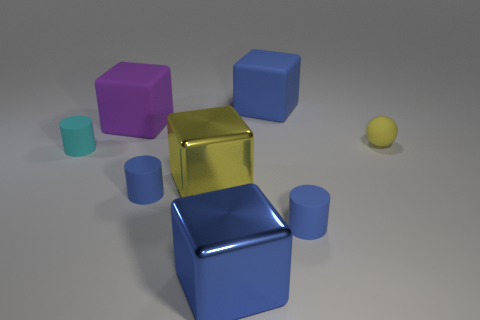Subtract 1 blocks. How many blocks are left? 3 Subtract all green spheres. Subtract all red cubes. How many spheres are left? 1 Add 1 purple things. How many objects exist? 9 Subtract all spheres. How many objects are left? 7 Add 2 tiny cyan rubber cylinders. How many tiny cyan rubber cylinders are left? 3 Add 7 large purple blocks. How many large purple blocks exist? 8 Subtract 0 green blocks. How many objects are left? 8 Subtract all small blue cylinders. Subtract all big blue objects. How many objects are left? 4 